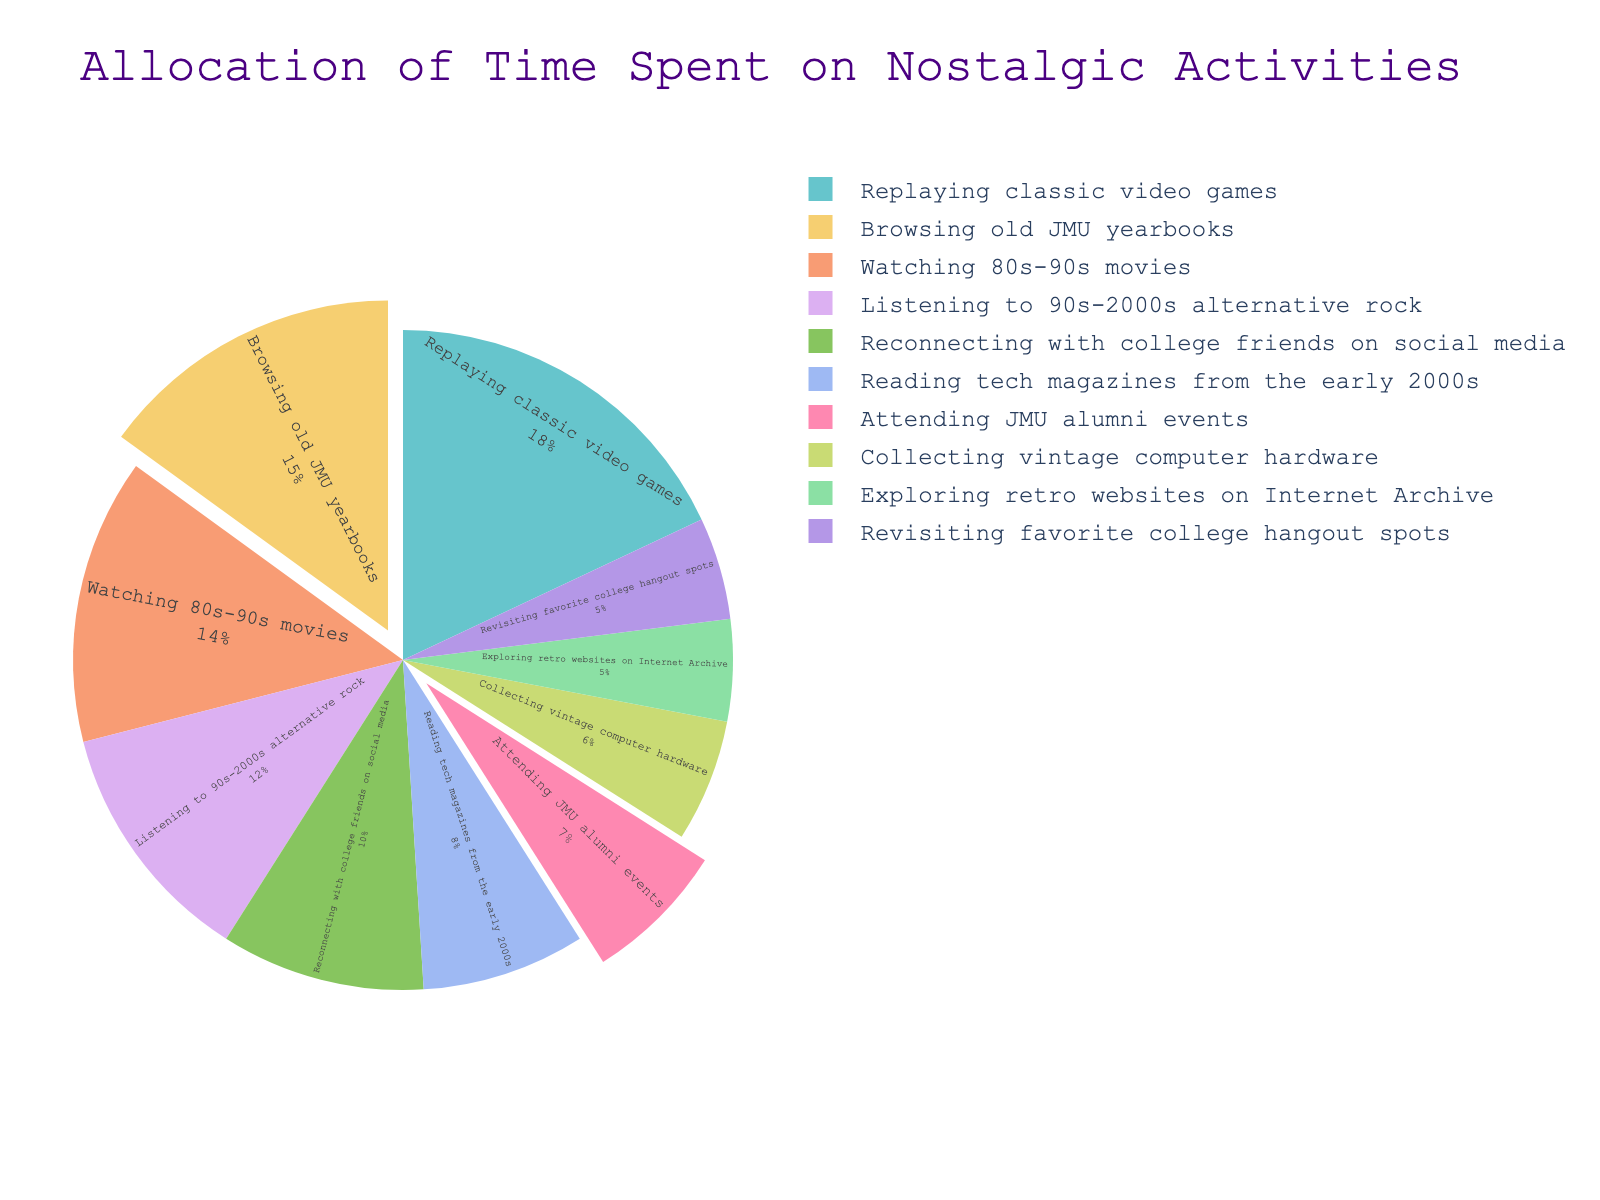Which activity takes up the largest portion of nostalgic activities? The largest portion can be identified by looking at the slice with the biggest percentage. "Replaying classic video games" has the highest value of 18%.
Answer: Replaying classic video games How much more time is spent browsing old JMU yearbooks compared to attending JMU alumni events? Subtract the percentage of attending JMU alumni events (7%) from the percentage of browsing old JMU yearbooks (15%). 15% - 7% = 8%.
Answer: 8% What are the combined percentages of activities related to JMU? Add the percentages for browsing old JMU yearbooks (15%) and attending JMU alumni events (7%). 15% + 7% = 22%.
Answer: 22% Which activity has a smaller percentage: collecting vintage computer hardware or exploring retro websites on Internet Archive? Compare the percentages directly. Collecting vintage computer hardware is 6%, while exploring retro websites on Internet Archive is 5%.
Answer: Exploring retro websites on Internet Archive What is the difference in percentage between watching 80s-90s movies and reconnecting with college friends on social media? Subtract the percentage of reconnecting with college friends on social media (10%) from the percentage of watching 80s-90s movies (14%). 14% - 10% = 4%.
Answer: 4% How much time is spent on activities related to media (watching movies, listening to music, reading magazines)? Sum the percentages for "Listening to 90s-2000s alternative rock" (12%), "Watching 80s-90s movies" (14%), and "Reading tech magazines from the early 2000s" (8%). 12% + 14% + 8% = 34%.
Answer: 34% What is the average percentage of time spent on the bottom three activities? Identify the three activities with the smallest percentages: exploring retro websites on Internet Archive (5%), revisiting favorite college hangout spots (5%), and collecting vintage computer hardware (6%). Calculate the average: (5% + 5% + 6%) / 3 = 5.33%.
Answer: 5.33% Which activities have equal percentages, and what are those percentages? Compare the percentages of all activities. Exploring retro websites on Internet Archive and revisiting favorite college hangout spots each have 5%.
Answer: Exploring retro websites on Internet Archive and revisiting favorite college hangout spots, both at 5% Is more time spent on listening to 90s-2000s alternative rock or reconnecting with college friends on social media? Compare the percentages directly. Listening to 90s-2000s alternative rock is 12%, while reconnecting with college friends on social media is 10%.
Answer: Listening to 90s-2000s alternative rock What activities are highlighted in the pie chart and why? The pull effect of the slices can be observed visually. "Browsing old JMU yearbooks" and "Attending JMU alumni events" have been pulled out to highlight them, possibly because they are related to JMU.
Answer: Browsing old JMU yearbooks and Attending JMU alumni events 